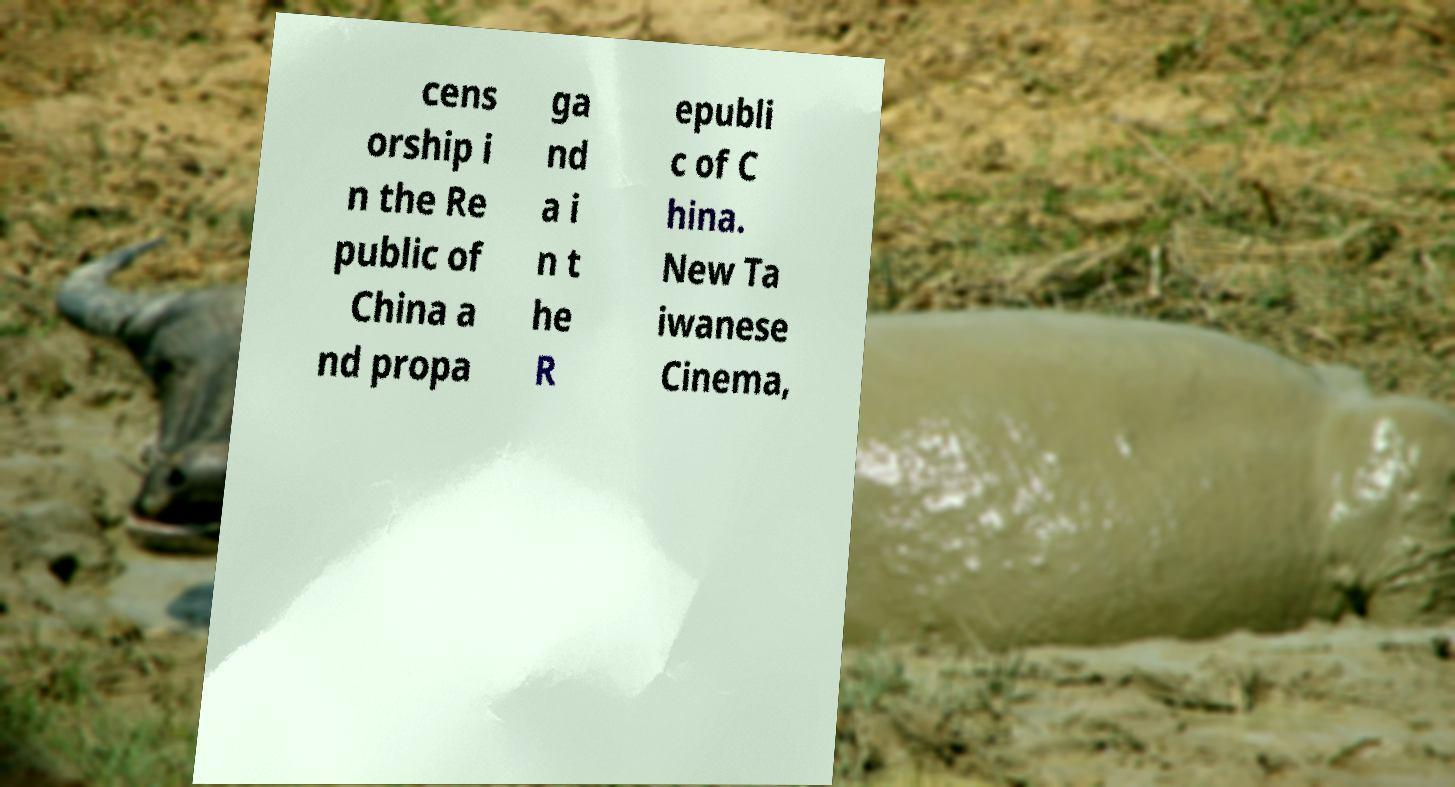There's text embedded in this image that I need extracted. Can you transcribe it verbatim? cens orship i n the Re public of China a nd propa ga nd a i n t he R epubli c of C hina. New Ta iwanese Cinema, 